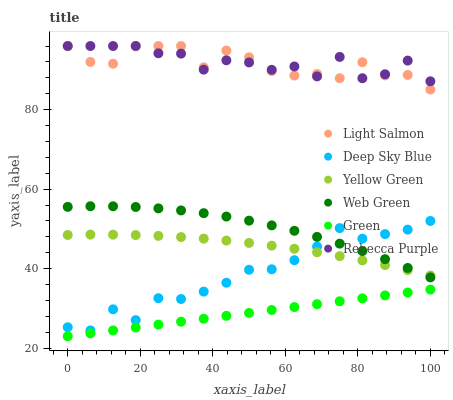Does Green have the minimum area under the curve?
Answer yes or no. Yes. Does Rebecca Purple have the maximum area under the curve?
Answer yes or no. Yes. Does Yellow Green have the minimum area under the curve?
Answer yes or no. No. Does Yellow Green have the maximum area under the curve?
Answer yes or no. No. Is Green the smoothest?
Answer yes or no. Yes. Is Light Salmon the roughest?
Answer yes or no. Yes. Is Yellow Green the smoothest?
Answer yes or no. No. Is Yellow Green the roughest?
Answer yes or no. No. Does Green have the lowest value?
Answer yes or no. Yes. Does Yellow Green have the lowest value?
Answer yes or no. No. Does Rebecca Purple have the highest value?
Answer yes or no. Yes. Does Yellow Green have the highest value?
Answer yes or no. No. Is Yellow Green less than Light Salmon?
Answer yes or no. Yes. Is Rebecca Purple greater than Deep Sky Blue?
Answer yes or no. Yes. Does Deep Sky Blue intersect Web Green?
Answer yes or no. Yes. Is Deep Sky Blue less than Web Green?
Answer yes or no. No. Is Deep Sky Blue greater than Web Green?
Answer yes or no. No. Does Yellow Green intersect Light Salmon?
Answer yes or no. No. 